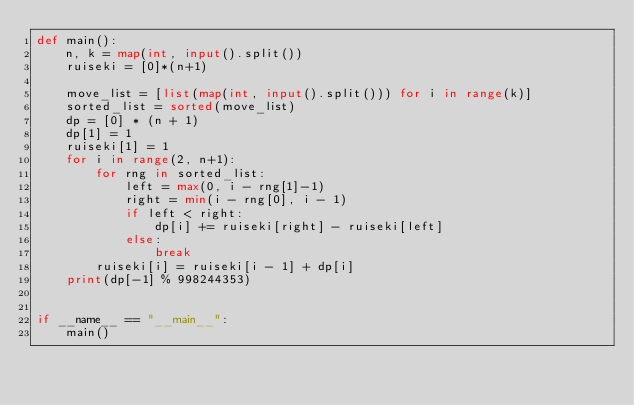Convert code to text. <code><loc_0><loc_0><loc_500><loc_500><_Python_>def main():
    n, k = map(int, input().split())
    ruiseki = [0]*(n+1)

    move_list = [list(map(int, input().split())) for i in range(k)]
    sorted_list = sorted(move_list)
    dp = [0] * (n + 1)
    dp[1] = 1
    ruiseki[1] = 1
    for i in range(2, n+1):
        for rng in sorted_list:
            left = max(0, i - rng[1]-1)
            right = min(i - rng[0], i - 1)
            if left < right:
                dp[i] += ruiseki[right] - ruiseki[left]
            else:
                break
        ruiseki[i] = ruiseki[i - 1] + dp[i]
    print(dp[-1] % 998244353)


if __name__ == "__main__":
    main()
</code> 